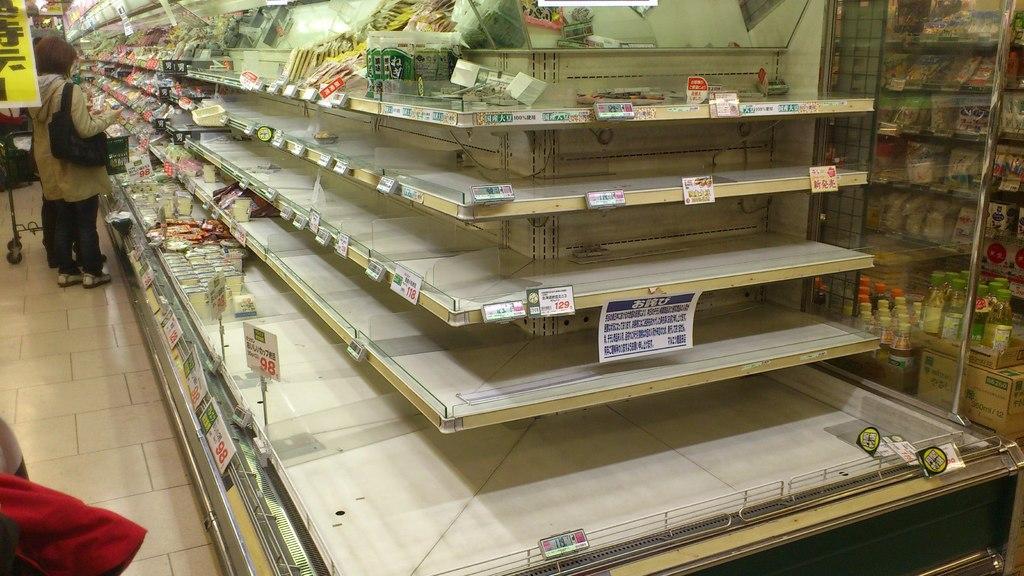Please provide a concise description of this image. In this image I can see different types of groceries on the racks. I can also see a person wearing cream color jacket, black color pant, I can also see a yellow color banner. In front I can see a red color cloth. 